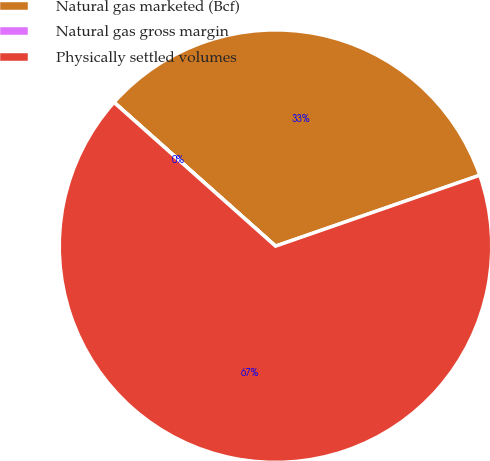Convert chart to OTSL. <chart><loc_0><loc_0><loc_500><loc_500><pie_chart><fcel>Natural gas marketed (Bcf)<fcel>Natural gas gross margin<fcel>Physically settled volumes<nl><fcel>33.1%<fcel>0.01%<fcel>66.9%<nl></chart> 